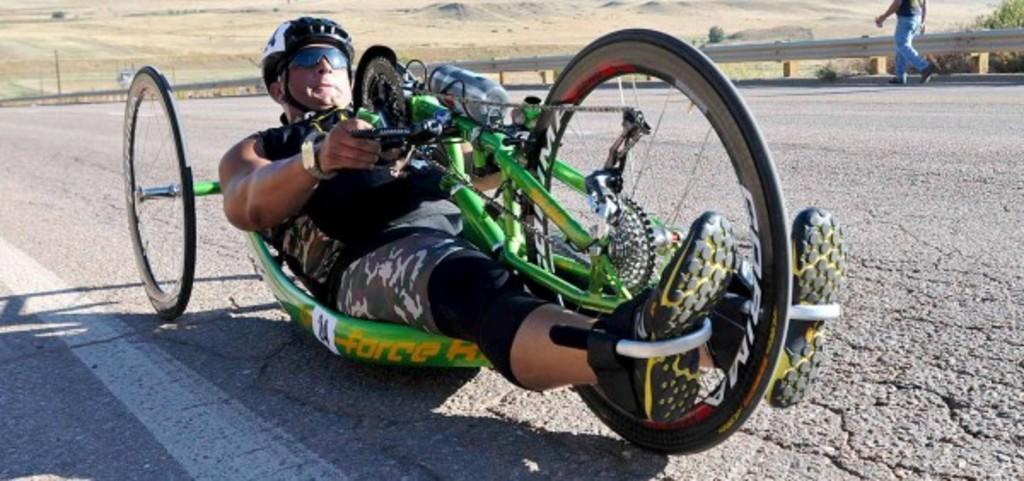Describe this image in one or two sentences. In this image I can see a person on the vehicle. In the background I can see an open land. I can see a person walking on the road. 